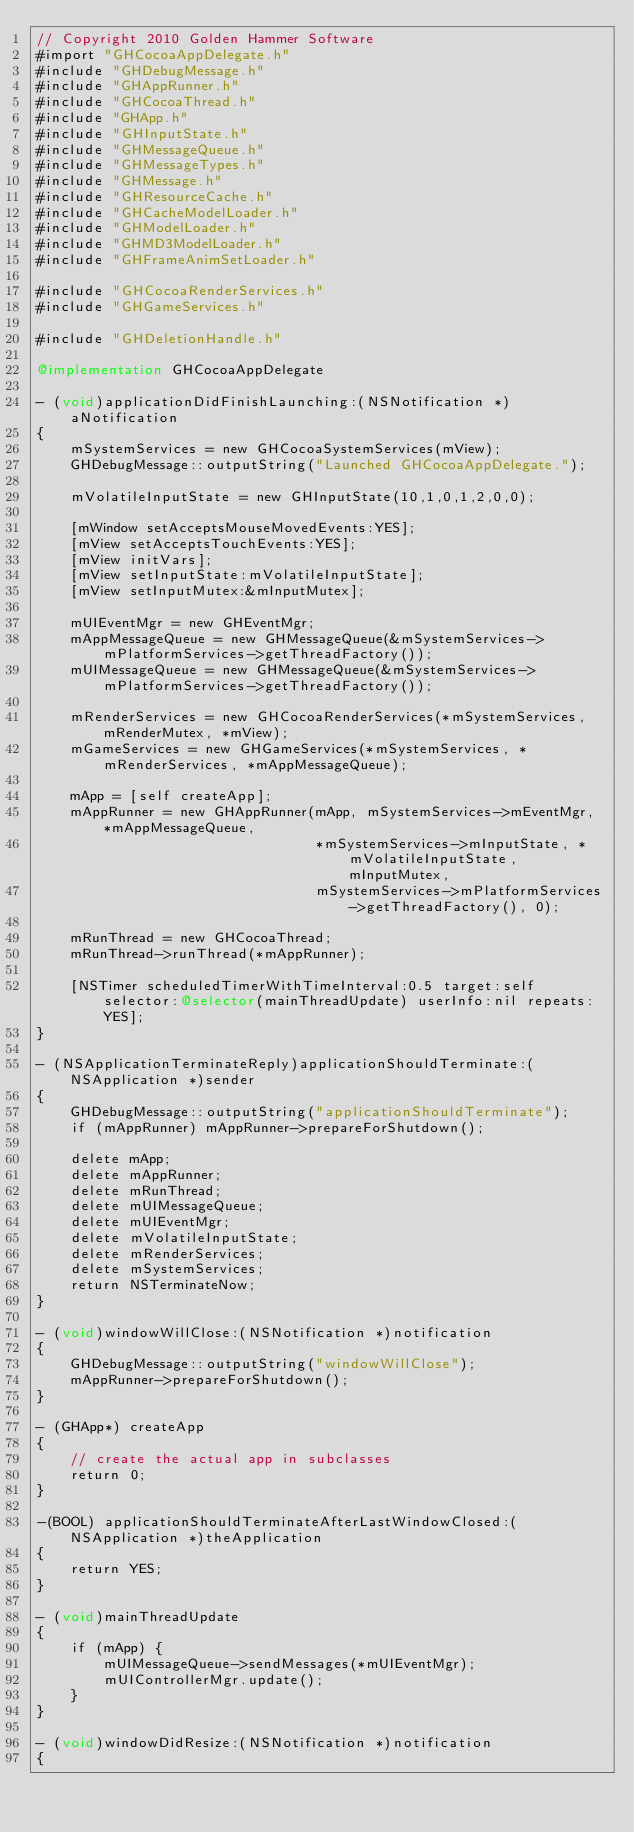<code> <loc_0><loc_0><loc_500><loc_500><_ObjectiveC_>// Copyright 2010 Golden Hammer Software
#import "GHCocoaAppDelegate.h"
#include "GHDebugMessage.h"
#include "GHAppRunner.h"
#include "GHCocoaThread.h"
#include "GHApp.h"
#include "GHInputState.h"
#include "GHMessageQueue.h"
#include "GHMessageTypes.h"
#include "GHMessage.h"
#include "GHResourceCache.h"
#include "GHCacheModelLoader.h"
#include "GHModelLoader.h"
#include "GHMD3ModelLoader.h"
#include "GHFrameAnimSetLoader.h"

#include "GHCocoaRenderServices.h"
#include "GHGameServices.h"

#include "GHDeletionHandle.h"

@implementation GHCocoaAppDelegate

- (void)applicationDidFinishLaunching:(NSNotification *)aNotification
{
    mSystemServices = new GHCocoaSystemServices(mView);
    GHDebugMessage::outputString("Launched GHCocoaAppDelegate.");

    mVolatileInputState = new GHInputState(10,1,0,1,2,0,0);
    
    [mWindow setAcceptsMouseMovedEvents:YES];
	[mView setAcceptsTouchEvents:YES];
    [mView initVars];
    [mView setInputState:mVolatileInputState];
    [mView setInputMutex:&mInputMutex];
    
    mUIEventMgr = new GHEventMgr;
    mAppMessageQueue = new GHMessageQueue(&mSystemServices->mPlatformServices->getThreadFactory());
    mUIMessageQueue = new GHMessageQueue(&mSystemServices->mPlatformServices->getThreadFactory());

    mRenderServices = new GHCocoaRenderServices(*mSystemServices, mRenderMutex, *mView);
    mGameServices = new GHGameServices(*mSystemServices, *mRenderServices, *mAppMessageQueue);
    
    mApp = [self createApp];
    mAppRunner = new GHAppRunner(mApp, mSystemServices->mEventMgr, *mAppMessageQueue, 
                                 *mSystemServices->mInputState, *mVolatileInputState, mInputMutex,
                                 mSystemServices->mPlatformServices->getThreadFactory(), 0);

	mRunThread = new GHCocoaThread;
	mRunThread->runThread(*mAppRunner);
	
	[NSTimer scheduledTimerWithTimeInterval:0.5 target:self selector:@selector(mainThreadUpdate) userInfo:nil repeats:YES];
}

- (NSApplicationTerminateReply)applicationShouldTerminate:(NSApplication *)sender
{
    GHDebugMessage::outputString("applicationShouldTerminate");
	if (mAppRunner) mAppRunner->prepareForShutdown();

    delete mApp;
    delete mAppRunner; 
    delete mRunThread;
    delete mUIMessageQueue;
    delete mUIEventMgr;
    delete mVolatileInputState;
    delete mRenderServices;
    delete mSystemServices;
	return NSTerminateNow;
}

- (void)windowWillClose:(NSNotification *)notification
{
    GHDebugMessage::outputString("windowWillClose");
    mAppRunner->prepareForShutdown();
}

- (GHApp*) createApp
{
    // create the actual app in subclasses
    return 0;
}

-(BOOL) applicationShouldTerminateAfterLastWindowClosed:(NSApplication *)theApplication
{
	return YES;
}

- (void)mainThreadUpdate
{
	if (mApp) {
        mUIMessageQueue->sendMessages(*mUIEventMgr);
        mUIControllerMgr.update();
	}
}

- (void)windowDidResize:(NSNotification *)notification
{</code> 